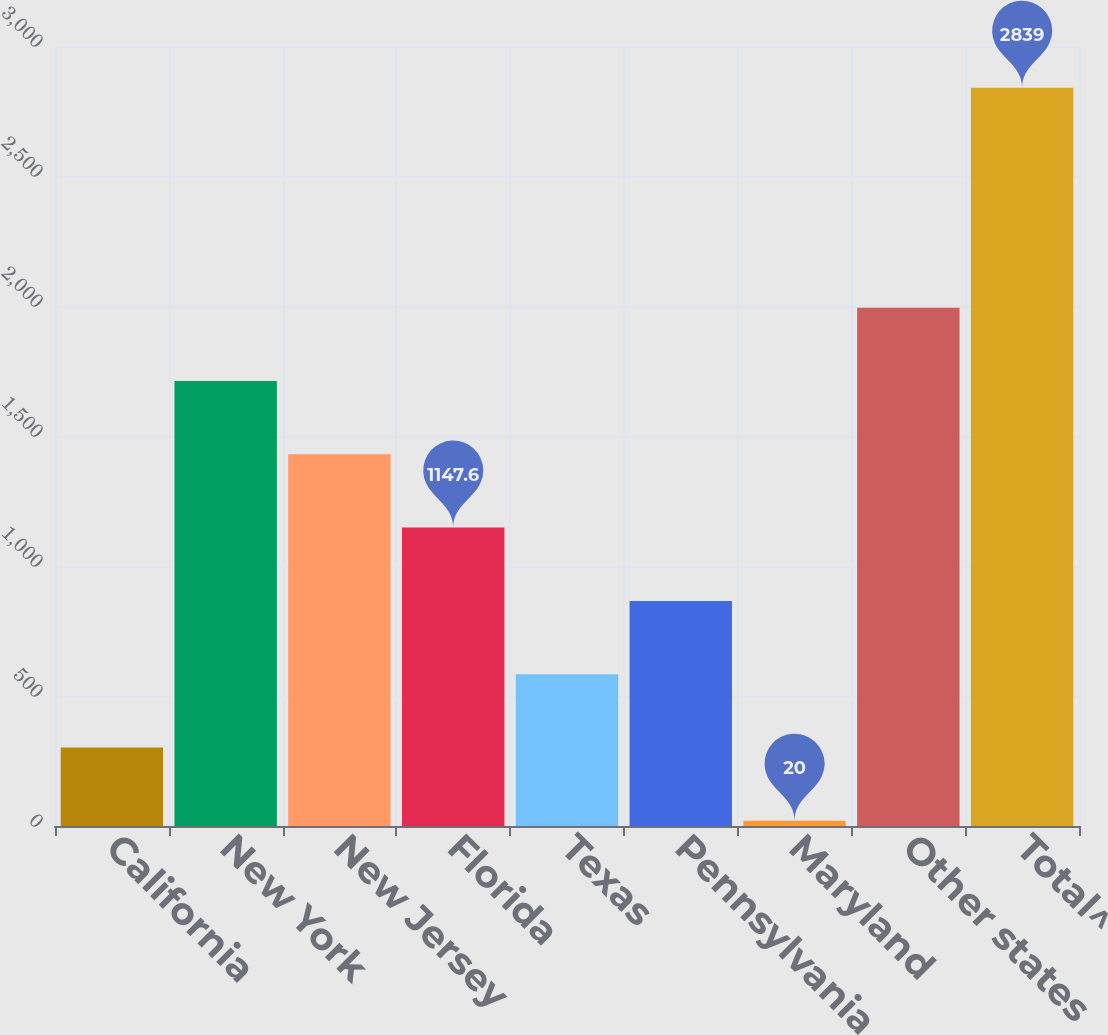Convert chart to OTSL. <chart><loc_0><loc_0><loc_500><loc_500><bar_chart><fcel>California<fcel>New York<fcel>New Jersey<fcel>Florida<fcel>Texas<fcel>Pennsylvania<fcel>Maryland<fcel>Other states<fcel>Total^<nl><fcel>301.9<fcel>1711.4<fcel>1429.5<fcel>1147.6<fcel>583.8<fcel>865.7<fcel>20<fcel>1993.3<fcel>2839<nl></chart> 